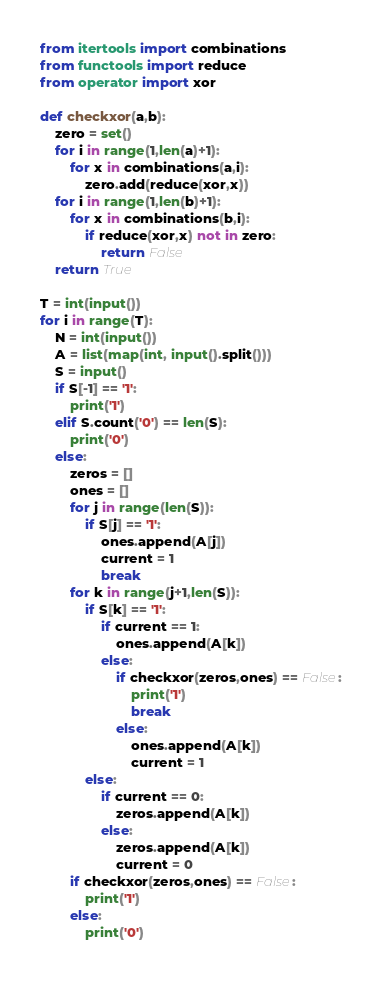<code> <loc_0><loc_0><loc_500><loc_500><_Python_>from itertools import combinations
from functools import reduce
from operator import xor

def checkxor(a,b):
    zero = set()
    for i in range(1,len(a)+1):
        for x in combinations(a,i):
            zero.add(reduce(xor,x))
    for i in range(1,len(b)+1):
        for x in combinations(b,i):
            if reduce(xor,x) not in zero:
                return False
    return True

T = int(input())
for i in range(T):
    N = int(input())
    A = list(map(int, input().split()))
    S = input()
    if S[-1] == '1':
        print('1')
    elif S.count('0') == len(S):
        print('0')
    else:
        zeros = []
        ones = []
        for j in range(len(S)):
            if S[j] == '1':
                ones.append(A[j])
                current = 1
                break
        for k in range(j+1,len(S)):
            if S[k] == '1':
                if current == 1:
                    ones.append(A[k])
                else:
                    if checkxor(zeros,ones) == False:
                        print('1')
                        break
                    else:
                        ones.append(A[k])
                        current = 1
            else:
                if current == 0:
                    zeros.append(A[k])
                else:
                    zeros.append(A[k])
                    current = 0
        if checkxor(zeros,ones) == False:
            print('1')
        else:
            print('0')</code> 